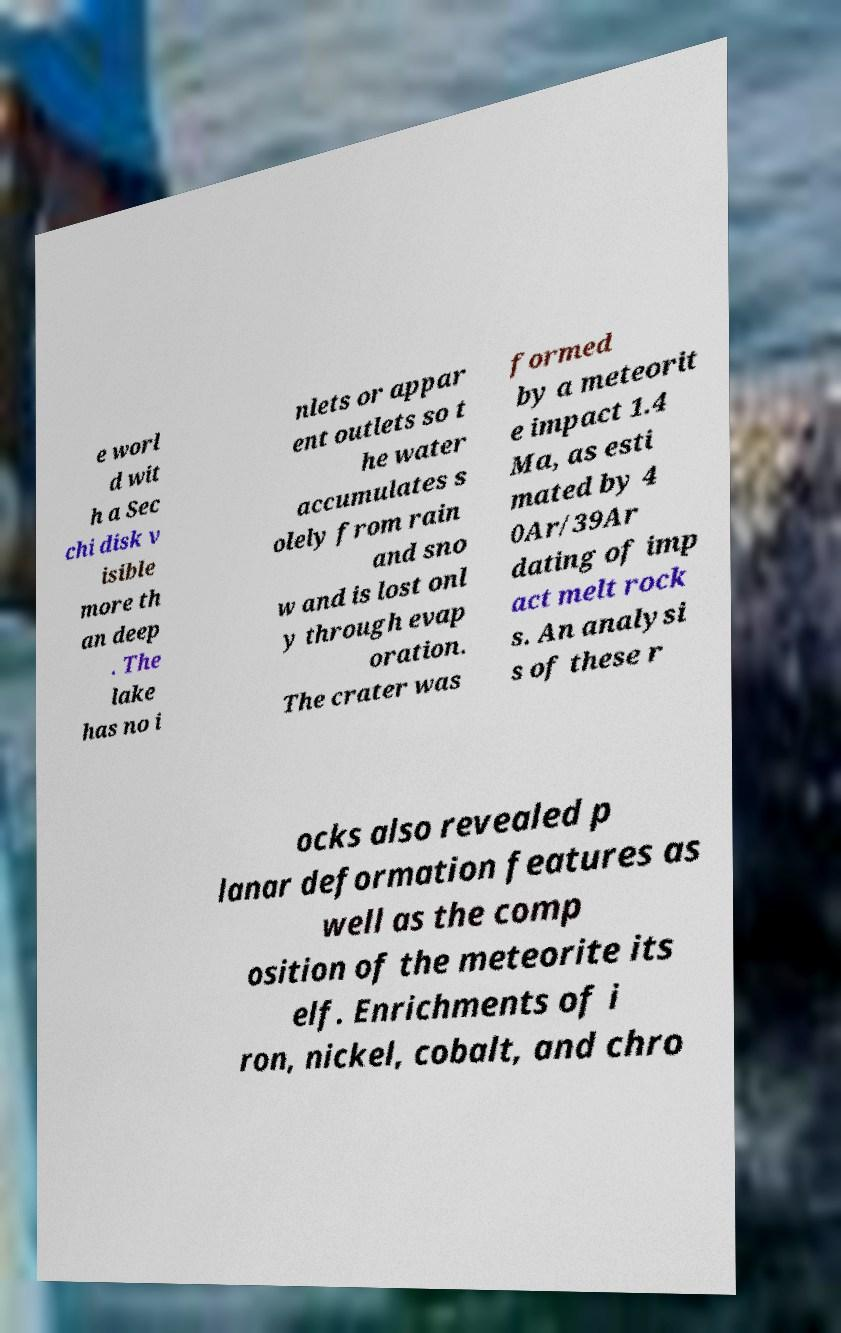What messages or text are displayed in this image? I need them in a readable, typed format. e worl d wit h a Sec chi disk v isible more th an deep . The lake has no i nlets or appar ent outlets so t he water accumulates s olely from rain and sno w and is lost onl y through evap oration. The crater was formed by a meteorit e impact 1.4 Ma, as esti mated by 4 0Ar/39Ar dating of imp act melt rock s. An analysi s of these r ocks also revealed p lanar deformation features as well as the comp osition of the meteorite its elf. Enrichments of i ron, nickel, cobalt, and chro 